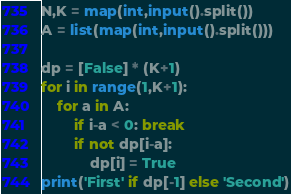<code> <loc_0><loc_0><loc_500><loc_500><_Python_>N,K = map(int,input().split())
A = list(map(int,input().split()))

dp = [False] * (K+1)
for i in range(1,K+1):
    for a in A:
        if i-a < 0: break
        if not dp[i-a]:
            dp[i] = True
print('First' if dp[-1] else 'Second')</code> 